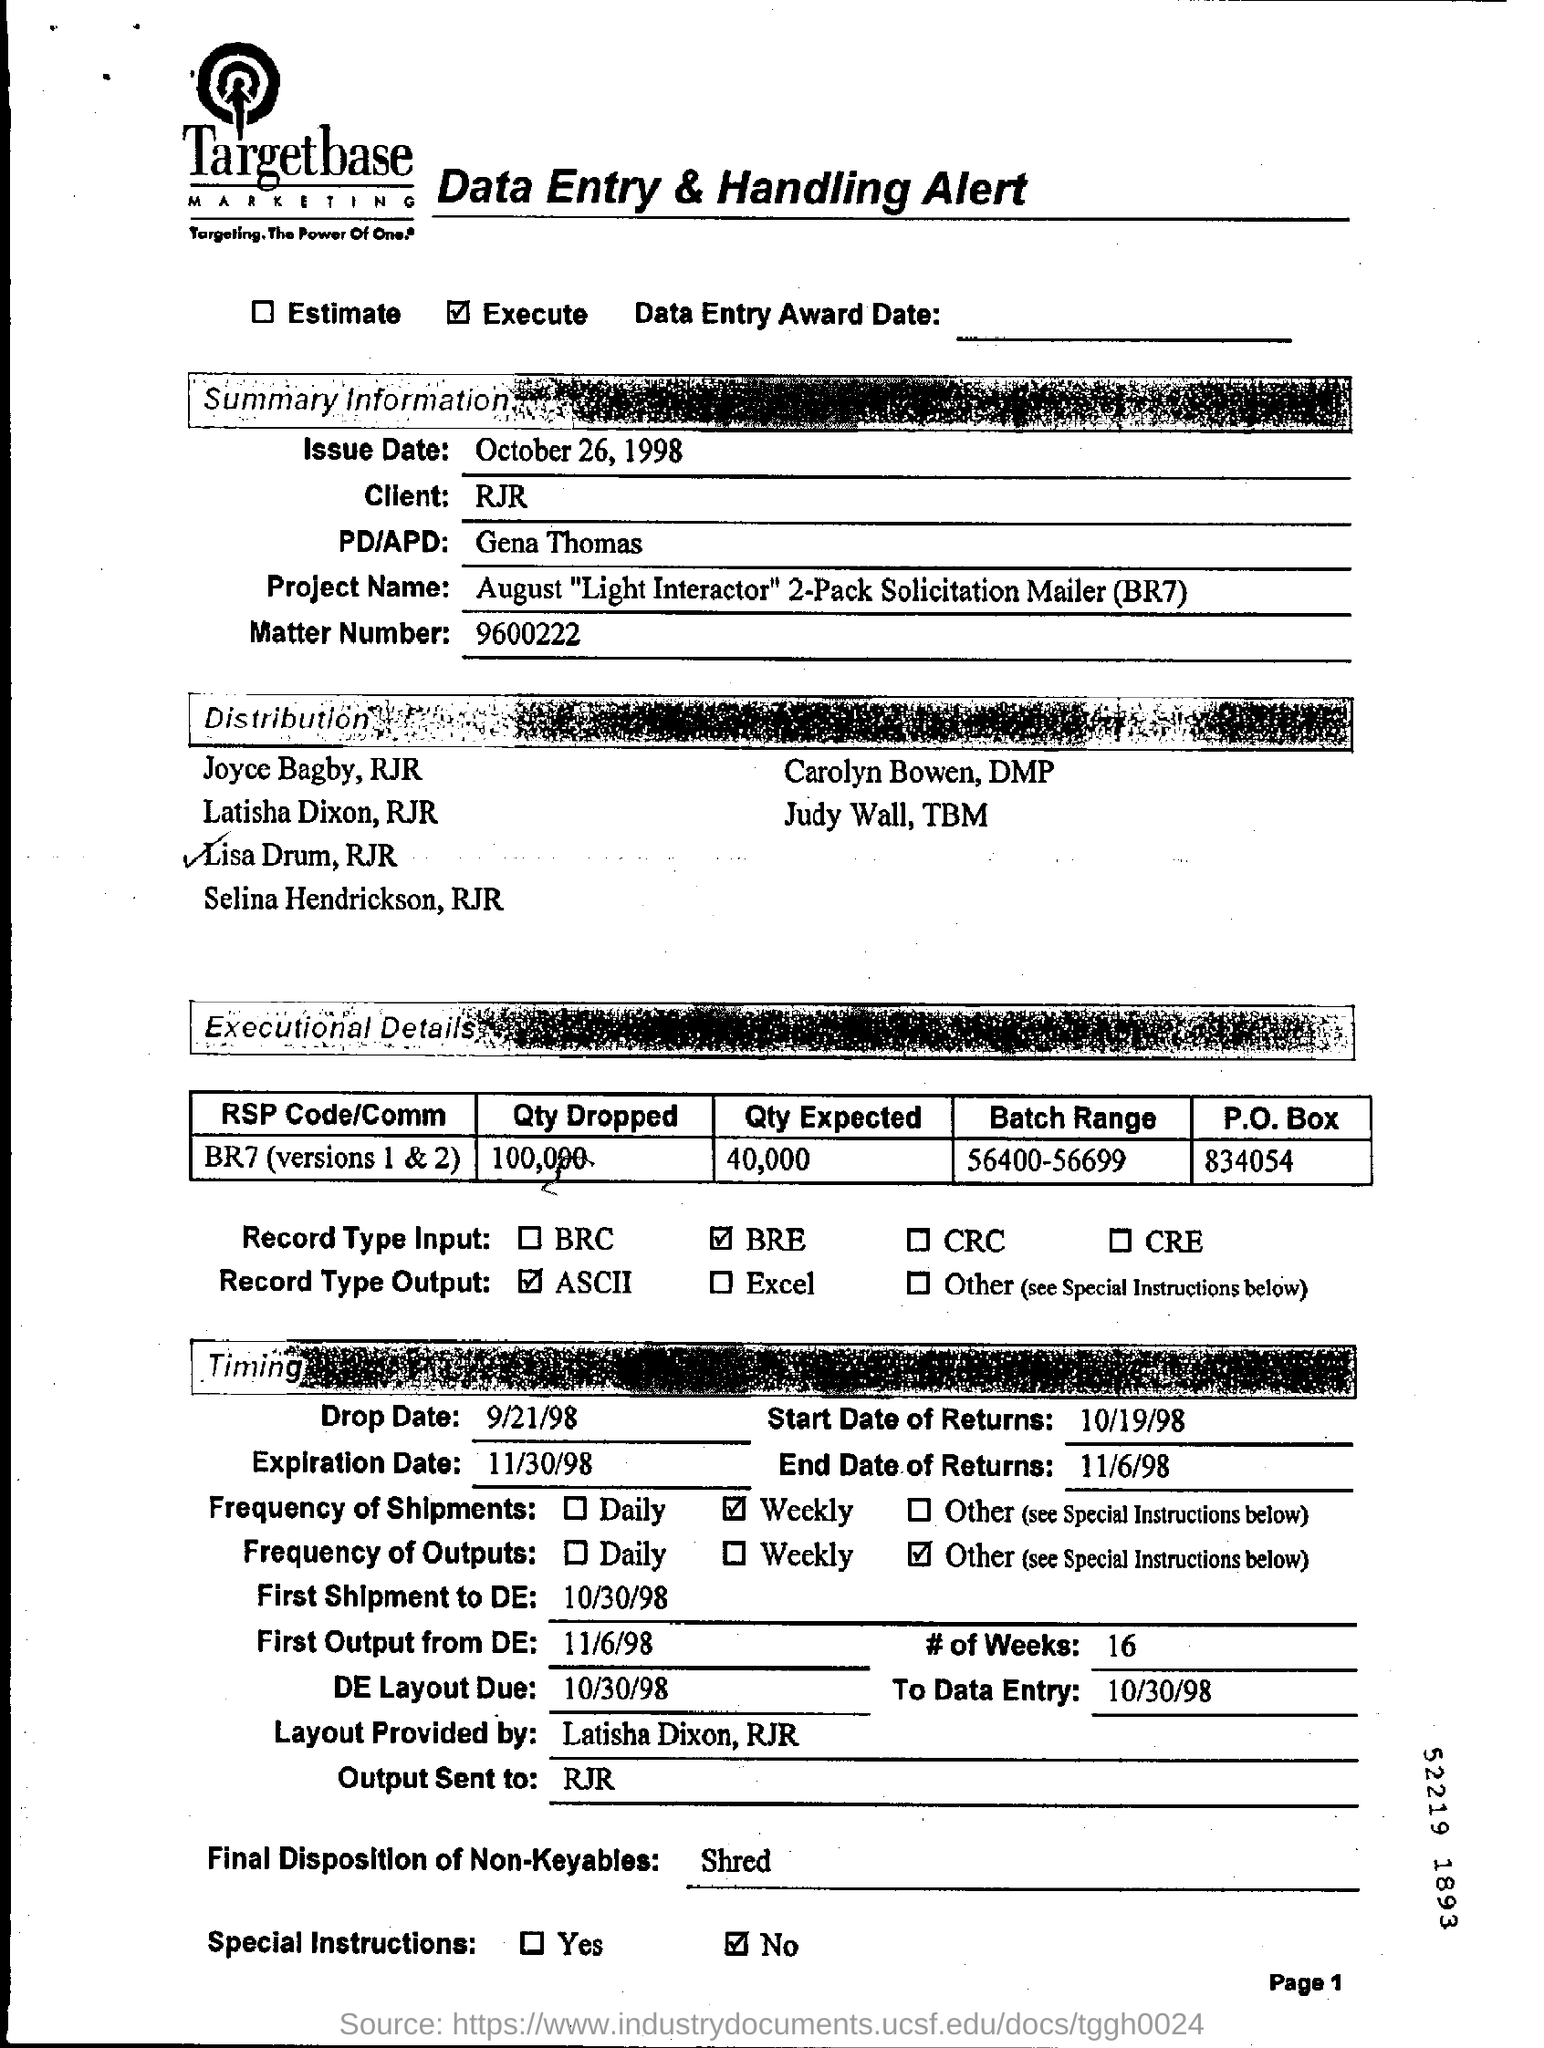What is the name of the client ?
Your answer should be very brief. RJR. What is the issue date ?
Make the answer very short. October 26, 1998. What is the pd/apd name ?
Provide a short and direct response. Gena thomas. What is the drop date ?
Provide a succinct answer. 9/21/98. How much quantity is dropped ?
Provide a short and direct response. 100,000. How much quantity is expected ?
Give a very brief answer. 40,000. What is the expiration date ?
Give a very brief answer. 11/30/98. What is the date of de layout due ?
Offer a very short reply. 10/30/98. To whom the  output is sent ?
Offer a very short reply. RJR. What is the matter number ?
Your response must be concise. 9600222. 